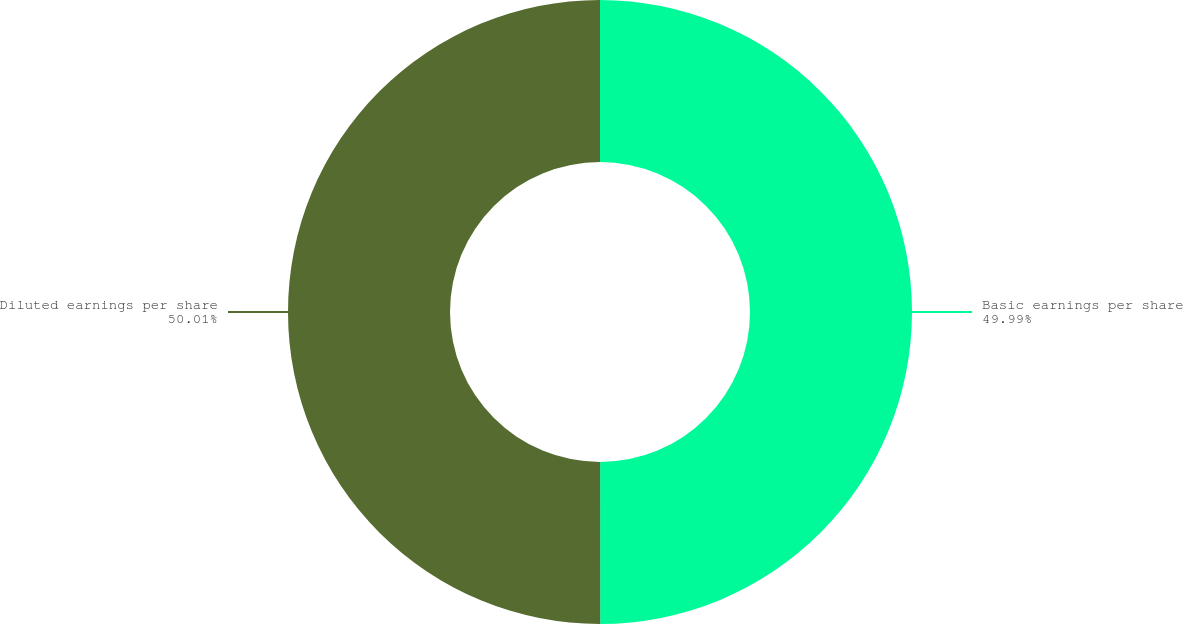Convert chart to OTSL. <chart><loc_0><loc_0><loc_500><loc_500><pie_chart><fcel>Basic earnings per share<fcel>Diluted earnings per share<nl><fcel>49.99%<fcel>50.01%<nl></chart> 